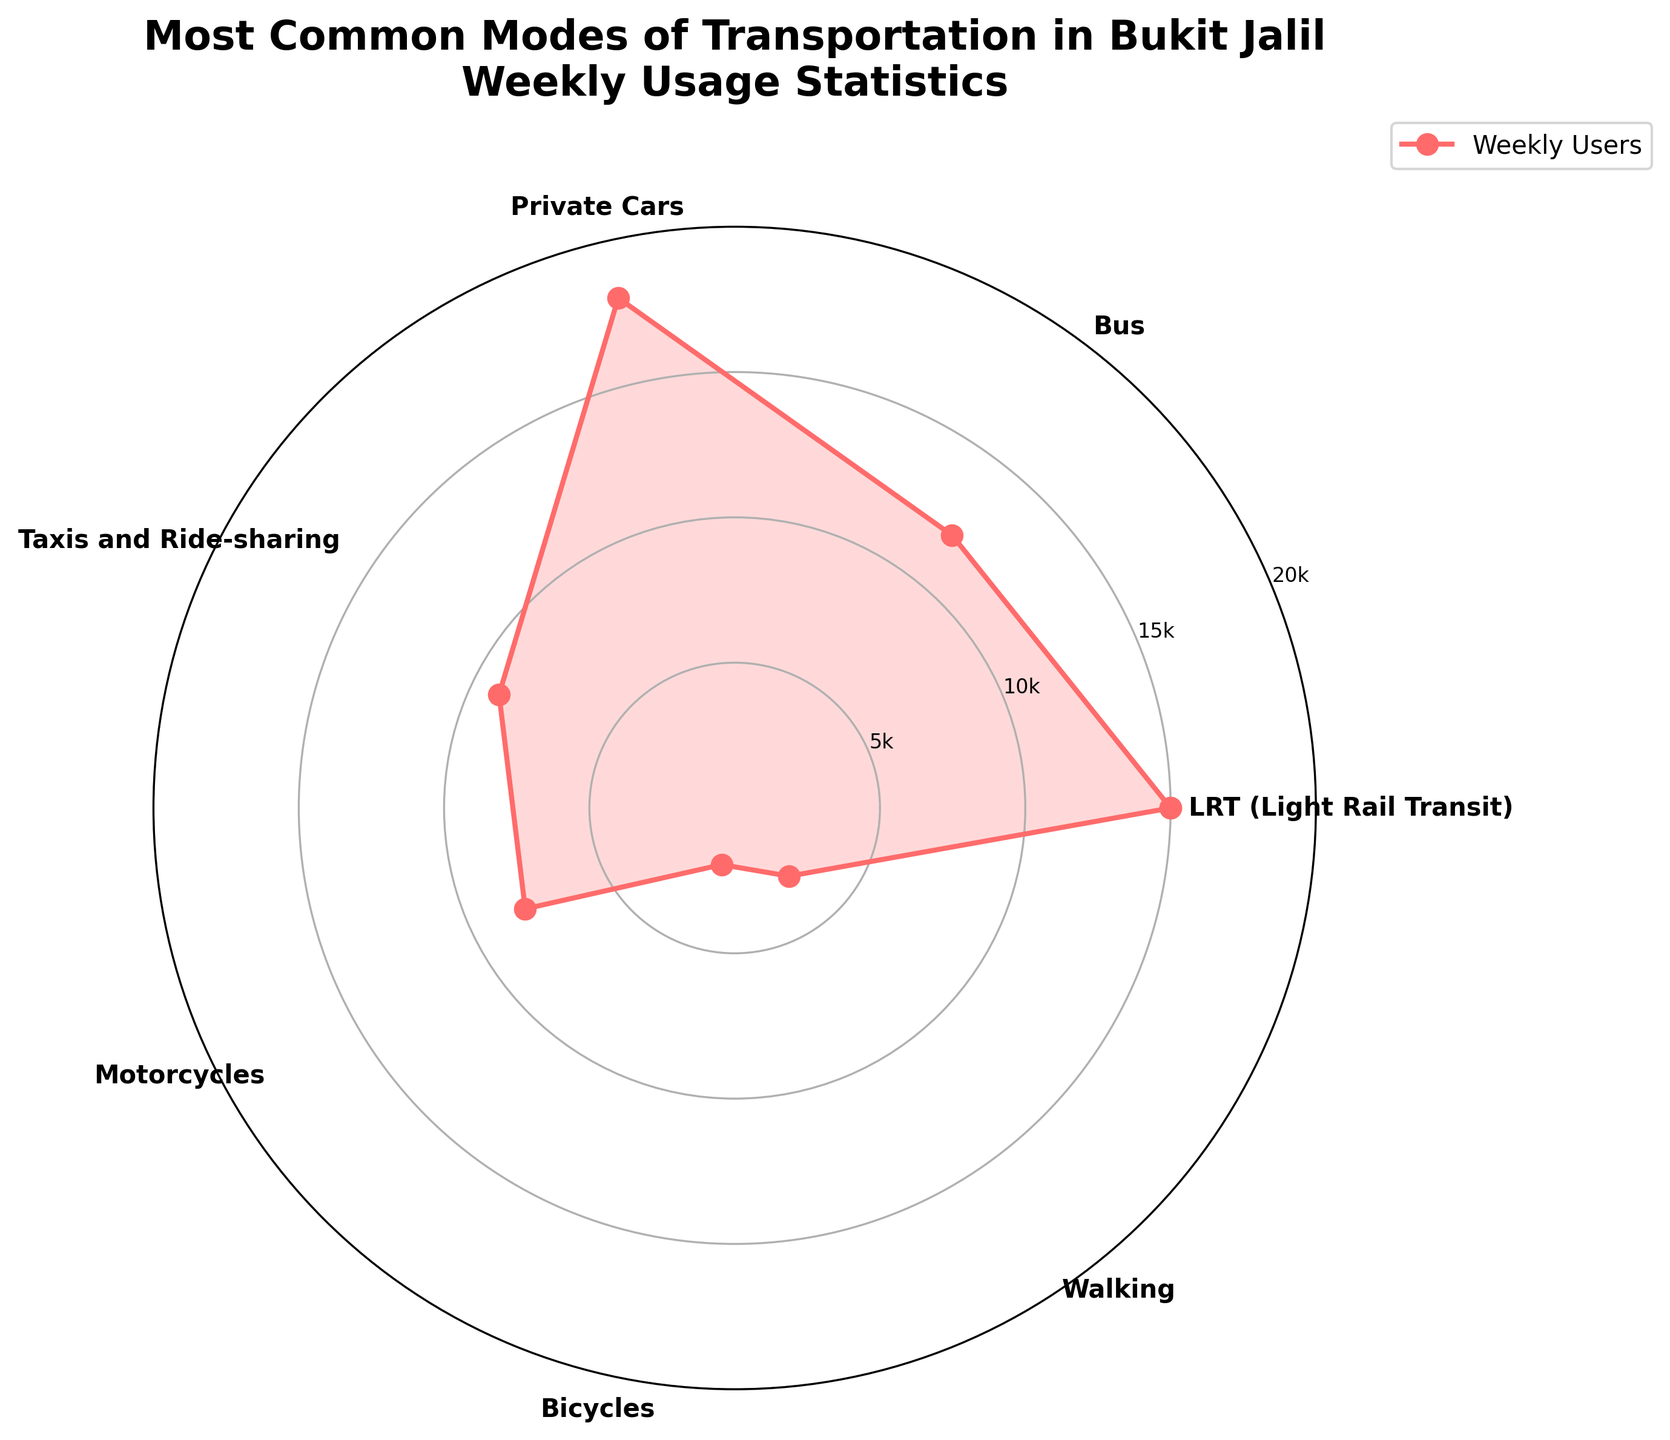What's the title of the figure? The title of the figure is displayed prominently at the top. It reads "Most Common Modes of Transportation in Bukit Jalil\nWeekly Usage Statistics," clearly indicating the content of the chart.
Answer: Most Common Modes of Transportation in Bukit Jalil\nWeekly Usage Statistics What is the mode of transportation with the highest weekly usage? The rose chart shows various modes of transportation with their respective weekly usage. The outermost petal corresponds to the highest value, which is for Private Cars.
Answer: Private Cars How many modes of transportation have less than 10,000 weekly users? Observing the different sectors in the rose chart, we identify the modes of transportation that fall inside the 10,000 user mark. These are Taxis and Ride-sharing, Motorcycles, Bicycles, and Walking, totaling four modes.
Answer: 4 What is the sum of weekly users for LRT and Buses? Adding the values for LRT (15,000) and Buses (12,000) will give the total weekly users for these two modes of transportation. 15000 + 12000 = 27000.
Answer: 27000 Which mode of transportation has fewer users: Motorcycles or Bicycles? By comparing the values on the rose chart, it's evident that Bicycle usage is lower with 2,000 users, whereas Motorcycle has 8,000 users.
Answer: Bicycles Is the weekly usage of Private Cars more than twice the usage of Buses? The weekly usage of Private Cars is 18,000, and twice the usage of Buses is 2 * 12,000 = 24,000. Since 18,000 is not more than 24,000, the answer is no.
Answer: No What is the average weekly usage of Taxis and Ride-sharing, Motorcycles, and Walking? The total weekly usage of Taxis and Ride-sharing, Motorcycles, and Walking is 9,000 + 8,000 + 3,000 = 20,000. The average is 20,000 / 3 ≈ 6,667.
Answer: 6,667 How does the weekly usage of LRT compare to that of Buses? Referring to the rose chart, the weekly usage of LRT (15,000) is higher than that of Buses (12,000).
Answer: LRT is higher Which mode of transportation is the least used? The smallest petal in the rose chart represents Bicycles with a weekly usage of 2,000 users.
Answer: Bicycles 